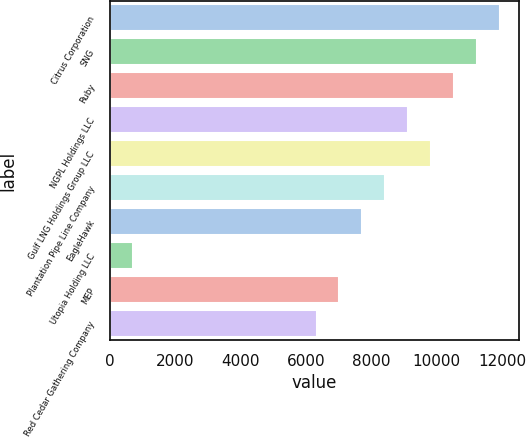Convert chart to OTSL. <chart><loc_0><loc_0><loc_500><loc_500><bar_chart><fcel>Citrus Corporation<fcel>SNG<fcel>Ruby<fcel>NGPL Holdings LLC<fcel>Gulf LNG Holdings Group LLC<fcel>Plantation Pipe Line Company<fcel>EagleHawk<fcel>Utopia Holding LLC<fcel>MEP<fcel>Red Cedar Gathering Company<nl><fcel>11928.4<fcel>11228.2<fcel>10528<fcel>9127.6<fcel>9827.8<fcel>8427.4<fcel>7727.2<fcel>725.2<fcel>7027<fcel>6326.8<nl></chart> 